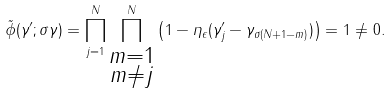<formula> <loc_0><loc_0><loc_500><loc_500>\tilde { \phi } ( \gamma ^ { \prime } ; \sigma \gamma ) = \prod _ { j = 1 } ^ { N } \prod _ { \substack { m = 1 \\ m \ne j } } ^ { N } \left ( 1 - \eta _ { \epsilon } ( \gamma ^ { \prime } _ { j } - \gamma _ { \sigma ( N + 1 - m ) } ) \right ) = 1 \ne 0 .</formula> 